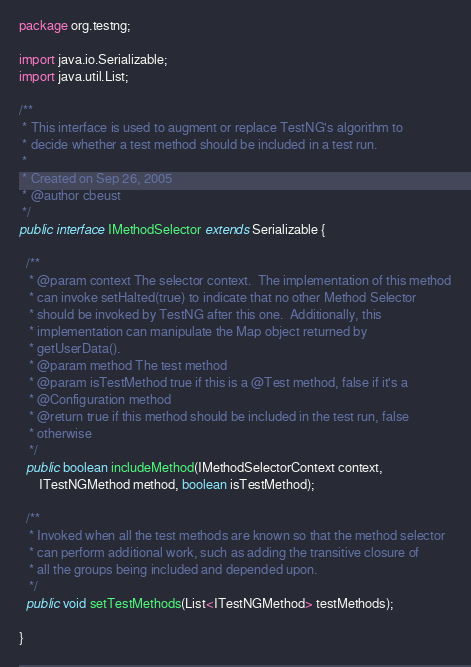<code> <loc_0><loc_0><loc_500><loc_500><_Java_>package org.testng;

import java.io.Serializable;
import java.util.List;

/**
 * This interface is used to augment or replace TestNG's algorithm to 
 * decide whether a test method should be included in a test run.
 * 
 * Created on Sep 26, 2005
 * @author cbeust
 */
public interface IMethodSelector extends Serializable {
  
  /**
   * @param context The selector context.  The implementation of this method
   * can invoke setHalted(true) to indicate that no other Method Selector
   * should be invoked by TestNG after this one.  Additionally, this
   * implementation can manipulate the Map object returned by
   * getUserData().
   * @param method The test method
   * @param isTestMethod true if this is a @Test method, false if it's a 
   * @Configuration method
   * @return true if this method should be included in the test run, false
   * otherwise
   */
  public boolean includeMethod(IMethodSelectorContext context,
      ITestNGMethod method, boolean isTestMethod);

  /**
   * Invoked when all the test methods are known so that the method selector
   * can perform additional work, such as adding the transitive closure of
   * all the groups being included and depended upon.
   */
  public void setTestMethods(List<ITestNGMethod> testMethods);
  
}
</code> 